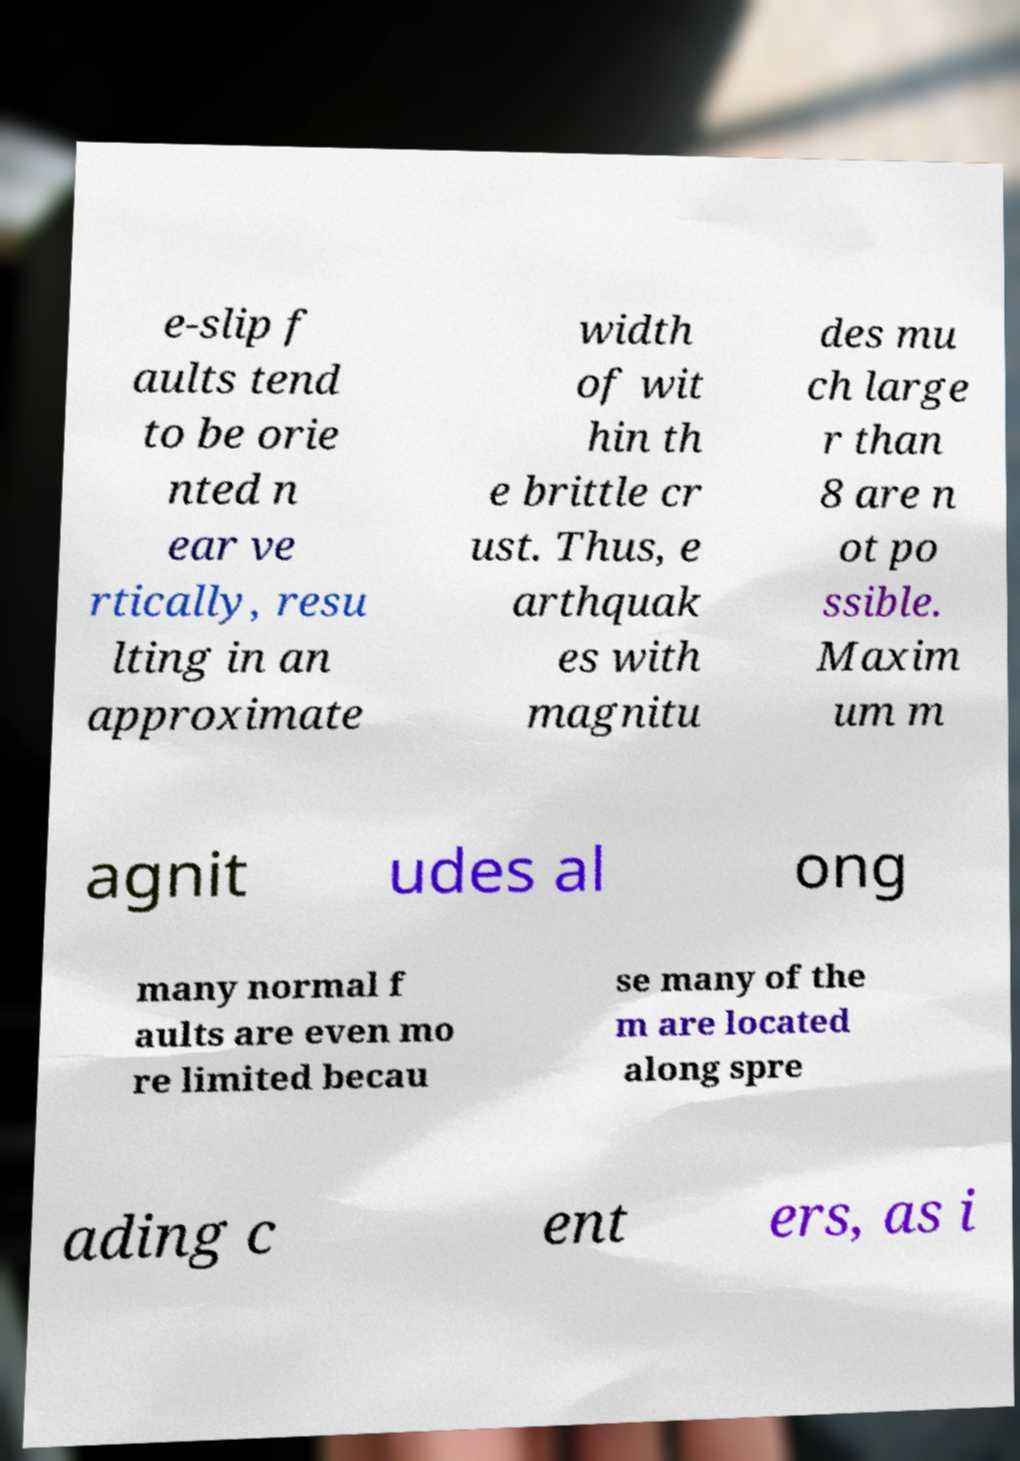Can you accurately transcribe the text from the provided image for me? e-slip f aults tend to be orie nted n ear ve rtically, resu lting in an approximate width of wit hin th e brittle cr ust. Thus, e arthquak es with magnitu des mu ch large r than 8 are n ot po ssible. Maxim um m agnit udes al ong many normal f aults are even mo re limited becau se many of the m are located along spre ading c ent ers, as i 